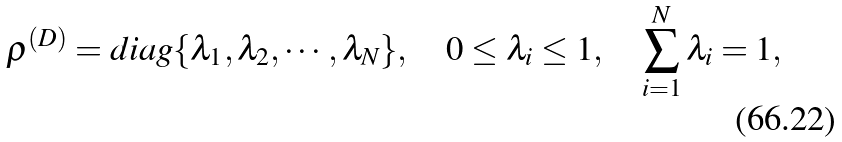Convert formula to latex. <formula><loc_0><loc_0><loc_500><loc_500>\rho ^ { ( D ) } = d i a g \{ \lambda _ { 1 } , \lambda _ { 2 } , \cdots , \lambda _ { N } \} , \quad 0 \leq \lambda _ { i } \leq 1 , \quad \sum _ { i = 1 } ^ { N } \lambda _ { i } = 1 ,</formula> 